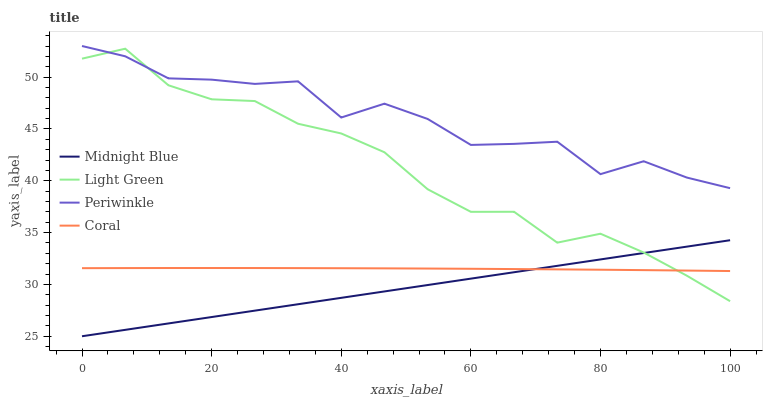Does Midnight Blue have the minimum area under the curve?
Answer yes or no. Yes. Does Periwinkle have the maximum area under the curve?
Answer yes or no. Yes. Does Periwinkle have the minimum area under the curve?
Answer yes or no. No. Does Midnight Blue have the maximum area under the curve?
Answer yes or no. No. Is Midnight Blue the smoothest?
Answer yes or no. Yes. Is Periwinkle the roughest?
Answer yes or no. Yes. Is Periwinkle the smoothest?
Answer yes or no. No. Is Midnight Blue the roughest?
Answer yes or no. No. Does Midnight Blue have the lowest value?
Answer yes or no. Yes. Does Periwinkle have the lowest value?
Answer yes or no. No. Does Periwinkle have the highest value?
Answer yes or no. Yes. Does Midnight Blue have the highest value?
Answer yes or no. No. Is Midnight Blue less than Periwinkle?
Answer yes or no. Yes. Is Periwinkle greater than Midnight Blue?
Answer yes or no. Yes. Does Light Green intersect Periwinkle?
Answer yes or no. Yes. Is Light Green less than Periwinkle?
Answer yes or no. No. Is Light Green greater than Periwinkle?
Answer yes or no. No. Does Midnight Blue intersect Periwinkle?
Answer yes or no. No. 